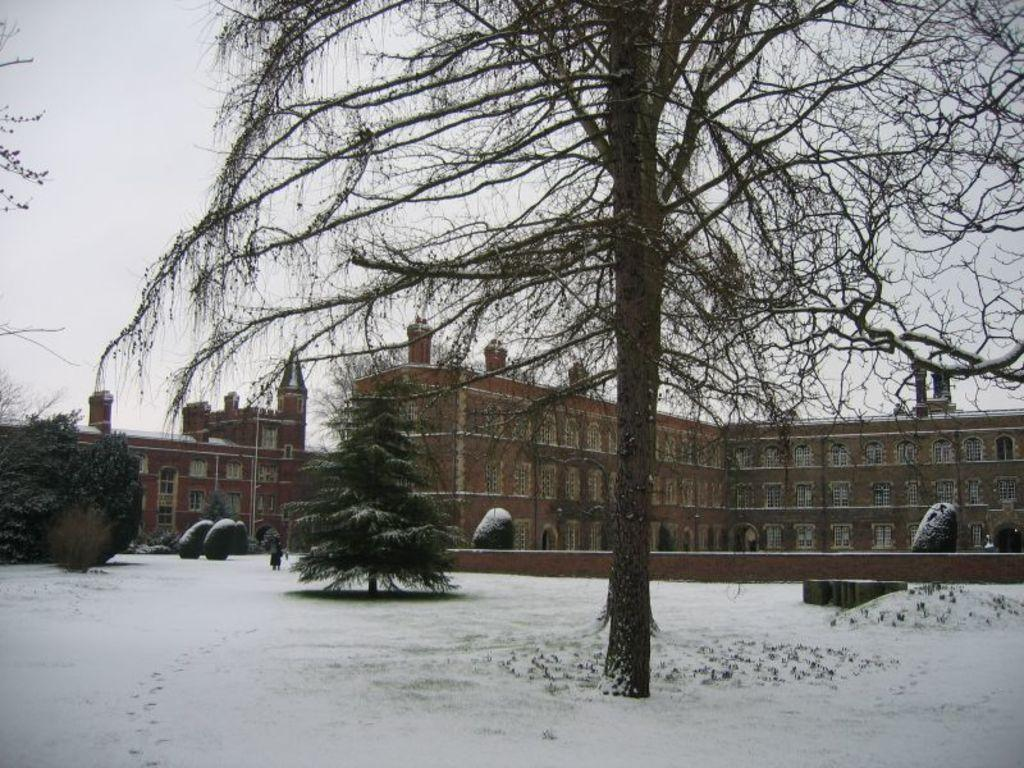What is covering the ground in the image? There is snow on the ground in the image. What type of natural elements can be seen in the image? There are trees in the image. What is the person in the image doing? There is a person standing on the snow in the image. How are the buildings in the image colored? Some of the buildings in the image are brown and cream in color. What can be seen in the background of the image? The sky is visible in the background of the image. What type of parcel is being delivered to the person in the image? There is no parcel being delivered in the image; it only shows a person standing on the snow. How does the snow affect the acoustics in the image? The text does not mention anything about acoustics, so we cannot determine how the snow affects it. 